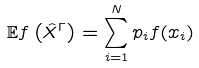Convert formula to latex. <formula><loc_0><loc_0><loc_500><loc_500>\mathbb { E } f \left ( \hat { X } ^ { \Gamma } \right ) = \sum _ { i = 1 } ^ { N } p _ { i } f ( x _ { i } )</formula> 